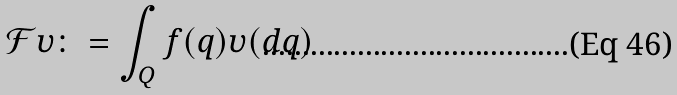<formula> <loc_0><loc_0><loc_500><loc_500>\mathcal { F } \upsilon \colon = \int _ { Q } f ( q ) \upsilon ( d q )</formula> 